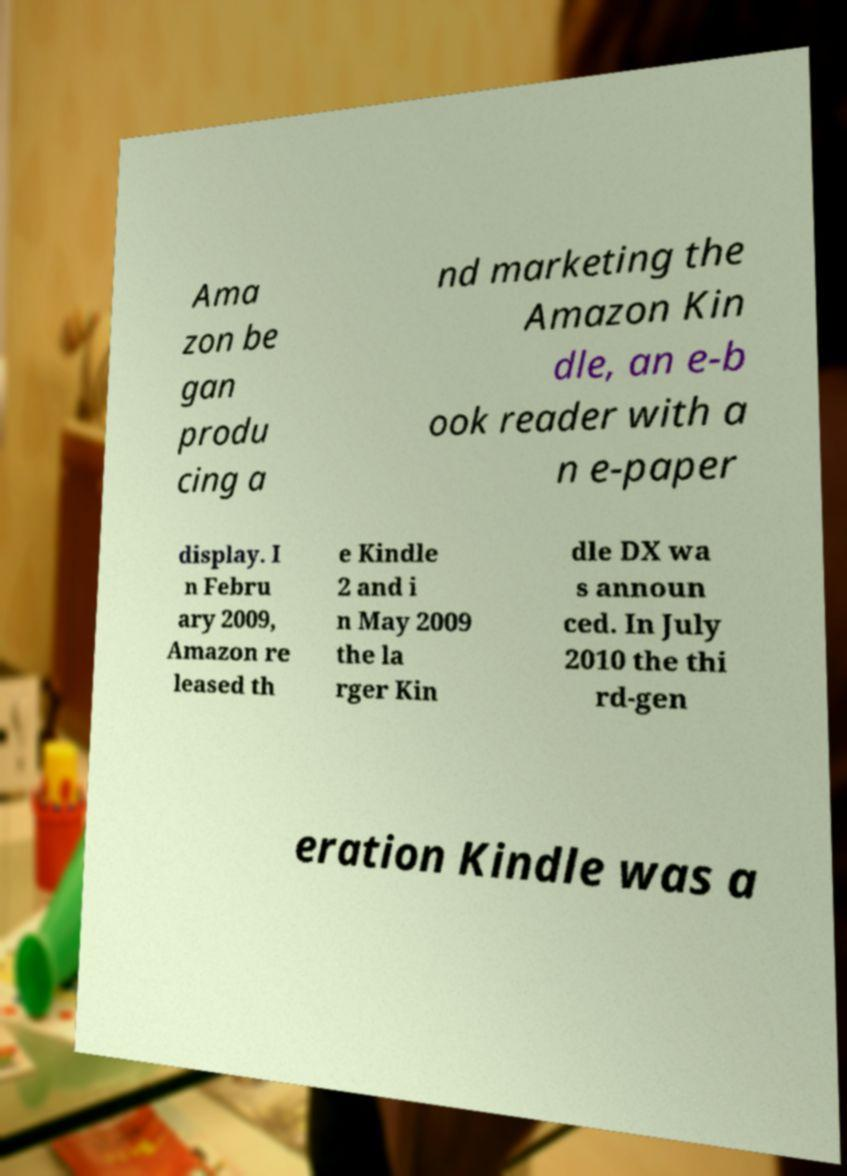There's text embedded in this image that I need extracted. Can you transcribe it verbatim? Ama zon be gan produ cing a nd marketing the Amazon Kin dle, an e-b ook reader with a n e-paper display. I n Febru ary 2009, Amazon re leased th e Kindle 2 and i n May 2009 the la rger Kin dle DX wa s announ ced. In July 2010 the thi rd-gen eration Kindle was a 